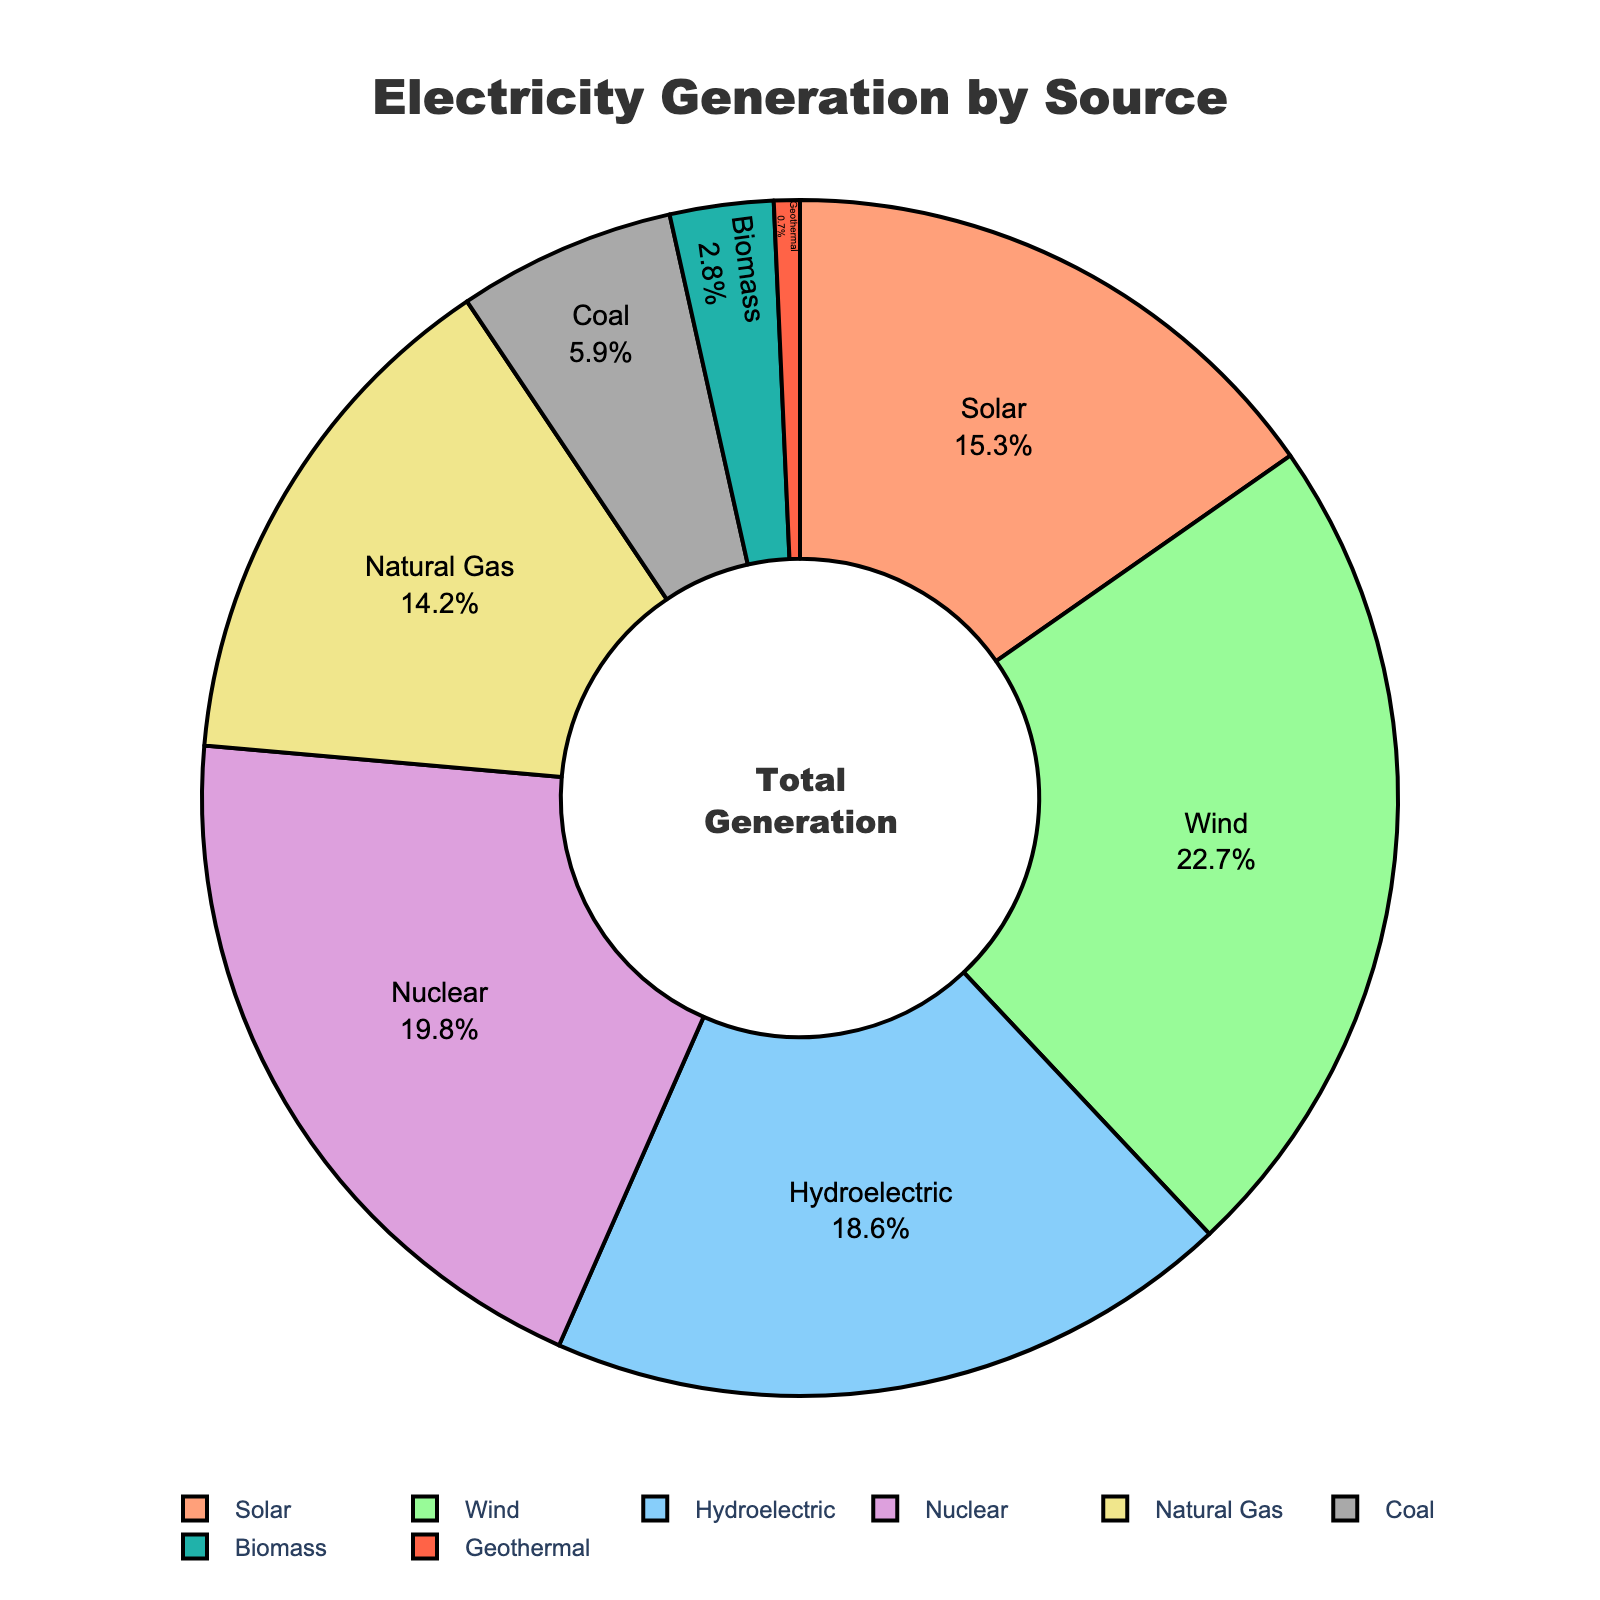What is the most significant source of electricity generation in this region? The pie chart shows that Wind has the largest segment. Comparing the percentages for each source, Wind has 22.7%, which is higher than any other source.
Answer: Wind Which two sources contribute equally to electricity generation? By examining the pie chart, we see that there are no two sources with the exact same percentage values.
Answer: None How much more electricity does Solar generate compared to Biomass? Solar generates 15.3% of electricity, while Biomass only generates 2.8%. Subtracting Biomass from Solar gives 15.3% - 2.8% = 12.5%.
Answer: 12.5% What is the total percentage of renewable sources (Solar, Wind, Hydroelectric, Biomass, and Geothermal)? To find this, sum the percentages of Solar (15.3%), Wind (22.7%), Hydroelectric (18.6%), Biomass (2.8%), and Geothermal (0.7%). The total is 15.3% + 22.7% + 18.6% + 2.8% + 0.7% = 60.1%.
Answer: 60.1% Which source contributes the least to electricity generation and what is its percentage? The smallest segment in the pie chart belongs to Geothermal with a percentage of 0.7%.
Answer: Geothermal, 0.7% How does the percentage of Natural Gas compare to Nuclear? The pie chart shows that Nuclear generates 19.8% of electricity, while Natural Gas contributes 14.2%. So, Nuclear's percentage is higher than Natural Gas by 5.6% (19.8% - 14.2%).
Answer: Nuclear is higher by 5.6% What is the combined percentage of electricity generation from Fossil Fuels (Natural Gas and Coal)? Adding the percentages of Natural Gas (14.2%) and Coal (5.9%), we get a total of 14.2% + 5.9% = 20.1%.
Answer: 20.1% Which section of the pie chart is colored in green and what percentage does it represent? Observing the color sections, the green segment corresponds to Wind, which represents 22.7%.
Answer: Wind, 22.7% If we exclude the top three sources of electricity generation, what is the remaining total percentage? The top three sources are Wind (22.7%), Nuclear (19.8%), and Hydroelectric (18.6%). Excluding these, we add the remaining percentages: Solar (15.3%), Natural Gas (14.2%), Coal (5.9%), Biomass (2.8%), and Geothermal (0.7%). The total is 15.3% + 14.2% + 5.9% + 2.8% + 0.7% = 38.9%.
Answer: 38.9% What proportion of the total electricity generation is due to Non-Renewable (Nuclear, Natural Gas, and Coal) sources? Adding the percentages of Nuclear (19.8%), Natural Gas (14.2%), and Coal (5.9%), we get 19.8% + 14.2% + 5.9% = 39.9%.
Answer: 39.9% 